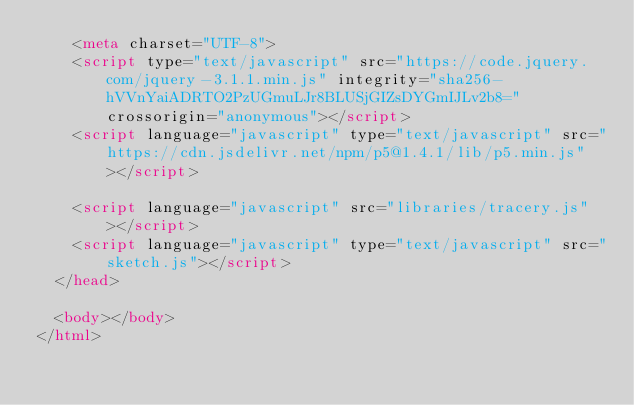Convert code to text. <code><loc_0><loc_0><loc_500><loc_500><_HTML_>    <meta charset="UTF-8">
    <script type="text/javascript" src="https://code.jquery.com/jquery-3.1.1.min.js" integrity="sha256-hVVnYaiADRTO2PzUGmuLJr8BLUSjGIZsDYGmIJLv2b8=" crossorigin="anonymous"></script>
    <script language="javascript" type="text/javascript" src="https://cdn.jsdelivr.net/npm/p5@1.4.1/lib/p5.min.js"></script>
    
    <script language="javascript" src="libraries/tracery.js"></script>
    <script language="javascript" type="text/javascript" src="sketch.js"></script>
  </head>

  <body></body>
</html>
</code> 